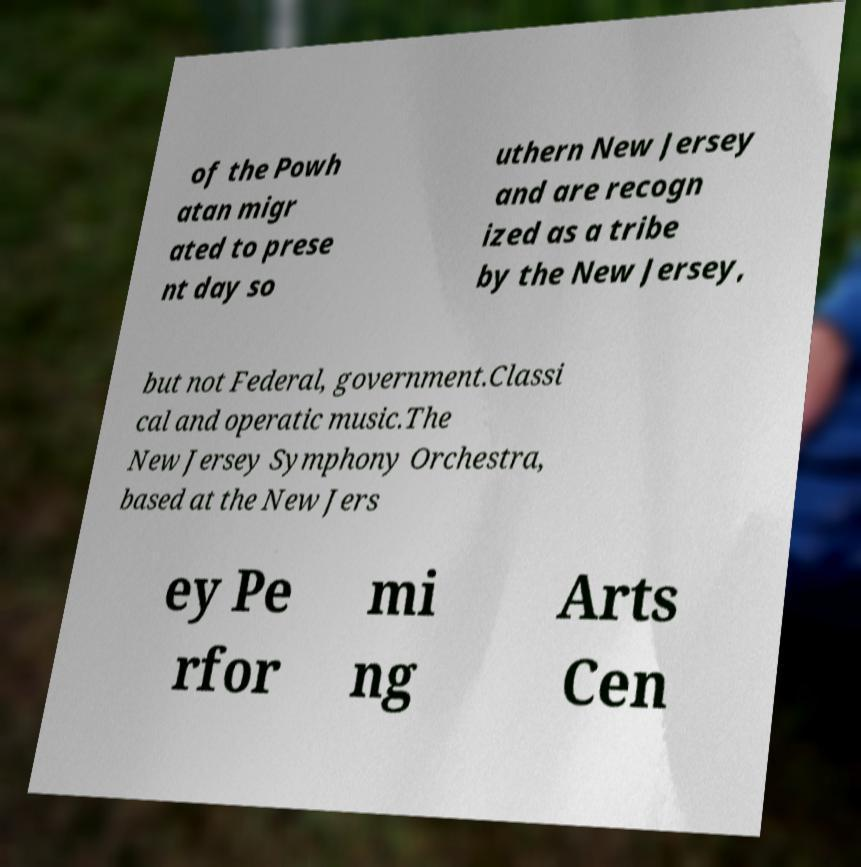Please identify and transcribe the text found in this image. of the Powh atan migr ated to prese nt day so uthern New Jersey and are recogn ized as a tribe by the New Jersey, but not Federal, government.Classi cal and operatic music.The New Jersey Symphony Orchestra, based at the New Jers ey Pe rfor mi ng Arts Cen 